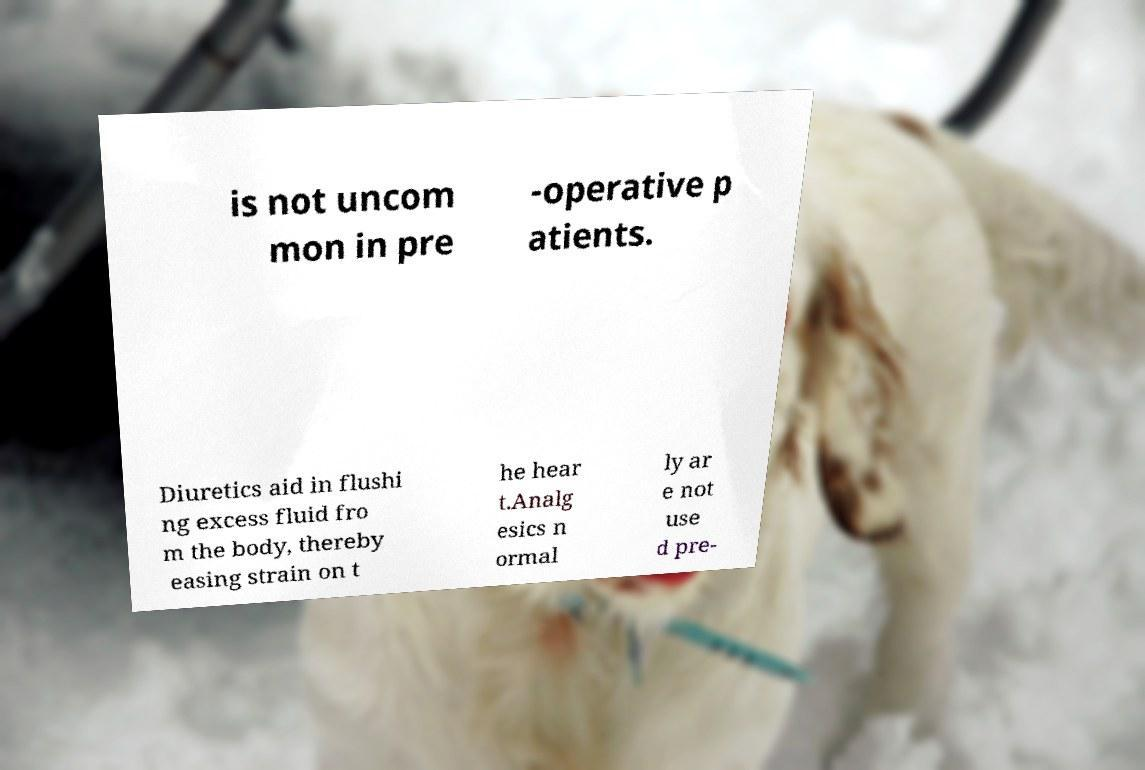For documentation purposes, I need the text within this image transcribed. Could you provide that? is not uncom mon in pre -operative p atients. Diuretics aid in flushi ng excess fluid fro m the body, thereby easing strain on t he hear t.Analg esics n ormal ly ar e not use d pre- 